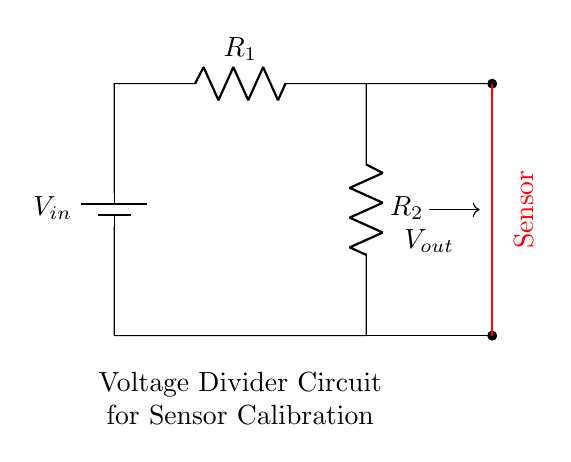What is the source voltage in the circuit? The source voltage is represented as V_in in the circuit diagram. It is located at the top of the circuit, marked as the input voltage.
Answer: V_in What components are in the circuit? The components visible in the circuit diagram include a battery, two resistors, and a sensor. The battery represents the power source, and the resistors are R_1 and R_2.
Answer: Battery, R_1, R_2, Sensor What is the function of the sensor in this circuit? The sensor in this configuration is intended to measure the output voltage V_out, which is derived from the voltage divider effect created by R_1 and R_2.
Answer: Measure output voltage What is the relationship between R_1 and R_2 in terms of output voltage? The output voltage V_out can be calculated using the voltage divider formula, which indicates that V_out is a fraction of V_in determined by the resistance values R_1 and R_2.
Answer: Voltage divider formula How does the voltage across the sensor compare to the input voltage? The voltage across the sensor, V_out, is less than V_in due to the voltage division created by R_1 and R_2. The output voltage will be a fraction of the input voltage based on the resistor values.
Answer: Less than V_in If R_1 is significantly larger than R_2, what happens to V_out? If R_1 is significantly larger than R_2, V_out approaches V_in, meaning most of the input voltage appears across the sensor as output. The output voltage increases as R_1 increases relative to R_2.
Answer: Approaches V_in What type of circuit is represented here? The circuit is a voltage divider circuit specifically designed for sensor calibration, where voltage division is used to obtain a desired output voltage for the sensor.
Answer: Voltage divider circuit 